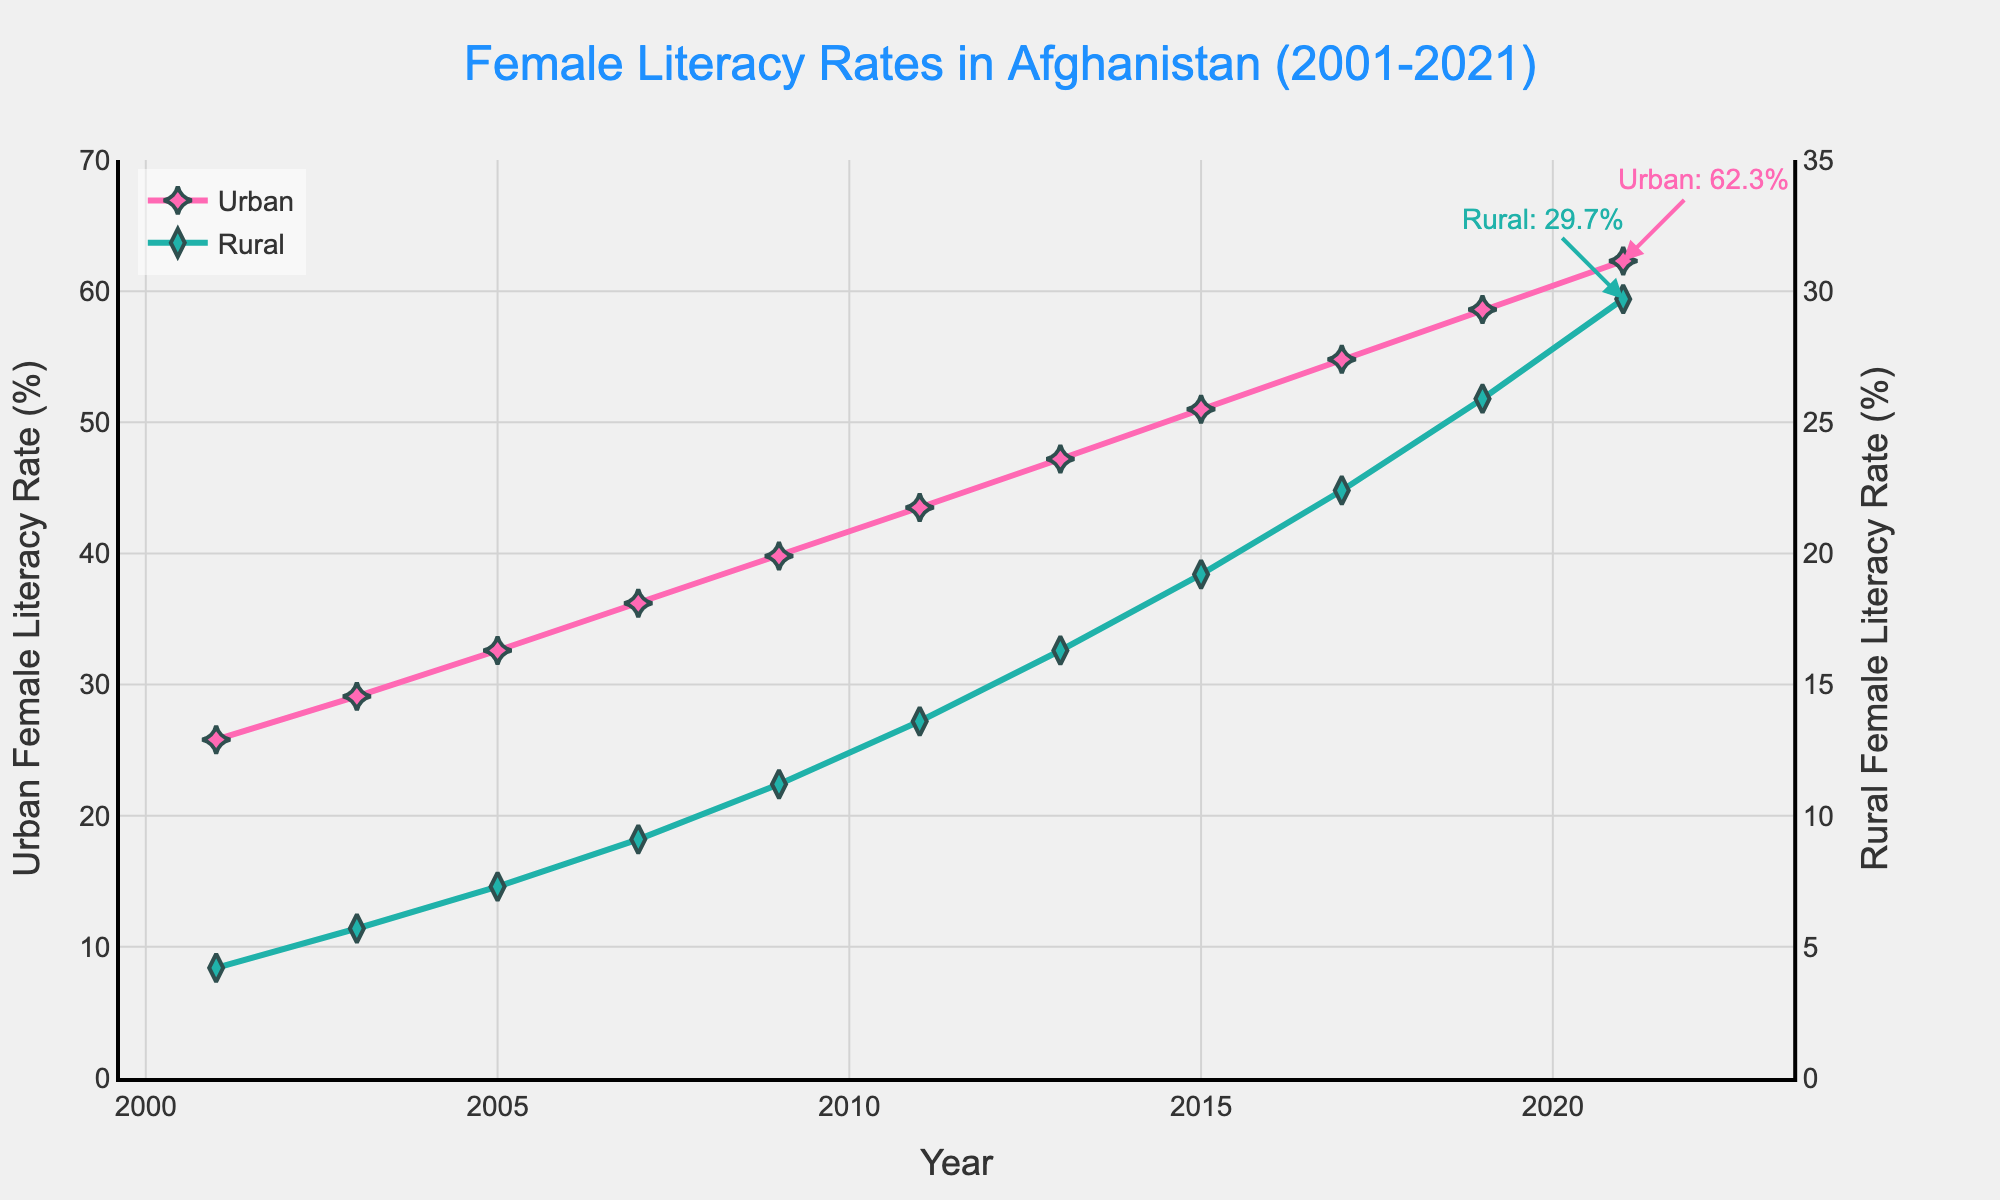What's the overall trend in urban female literacy rates from 2001 to 2021? The plot shows a consistent increase in urban female literacy rates from 25.8% in 2001 to 62.3% in 2021.
Answer: Increasing How much did the rural female literacy rate improve from 2001 to 2021? The rural female literacy rate increased from 4.2% in 2001 to 29.7% in 2021. The difference is 29.7% - 4.2% = 25.5%.
Answer: 25.5% In which year did the urban female literacy rate surpass 50%? By looking at the plot, the urban female literacy rate surpassed 50% in the year 2015.
Answer: 2015 What was the literacy rate gap between urban and rural females in 2021? In 2021, the urban literacy rate was 62.3% and the rural literacy rate was 29.7%. The gap is 62.3% - 29.7% = 32.6%.
Answer: 32.6% How did rural female literacy rate change between 2015 and 2017? Rural female literacy rate increased from 19.2% in 2015 to 22.4% in 2017. The change is 22.4% - 19.2% = 3.2%.
Answer: Increased by 3.2% Which year shows the highest increase in urban female literacy rate? To find this, we calculate the yearly increases: 2001-2003 = 3.3%, 2003-2005 = 3.5%, 2005-2007 = 3.6%, 2007-2009 = 3.6%, 2009-2011 = 3.7%, 2011-2013 = 3.7%, 2013-2015 = 3.8%, 2015-2017 = 3.8%, 2017-2019 = 3.8%, 2019-2021 = 3.7%. The highest increase occurred between 2013-2017 at 3.8%.
Answer: 2013-2017 How does the rate of increase in urban female literacy compare to the rural rate from 2001-2021? From 2001 to 2021, the urban female literacy increased by 62.3% - 25.8% = 36.5%, while the rural female literacy increased by 29.7% - 4.2% = 25.5%. The urban rate of increase is higher by 36.5% - 25.5% = 11%.
Answer: Urban rate is higher by 11% Between which consecutive years is the increase in rural female literacy rate the greatest? Calculate the yearly increases: 2001-2003 = 1.5%, 2003-2005 = 1.6%, 2005-2007 = 1.8%, 2007-2009 = 2.1%, 2009-2011 = 2.4%, 2011-2013 = 2.7%, 2013-2015 = 2.9%, 2015-2017 = 3.2%, 2017-2019 = 3.5%, 2019-2021 = 3.8%. The greatest increase is between 2019-2021.
Answer: 2019-2021 